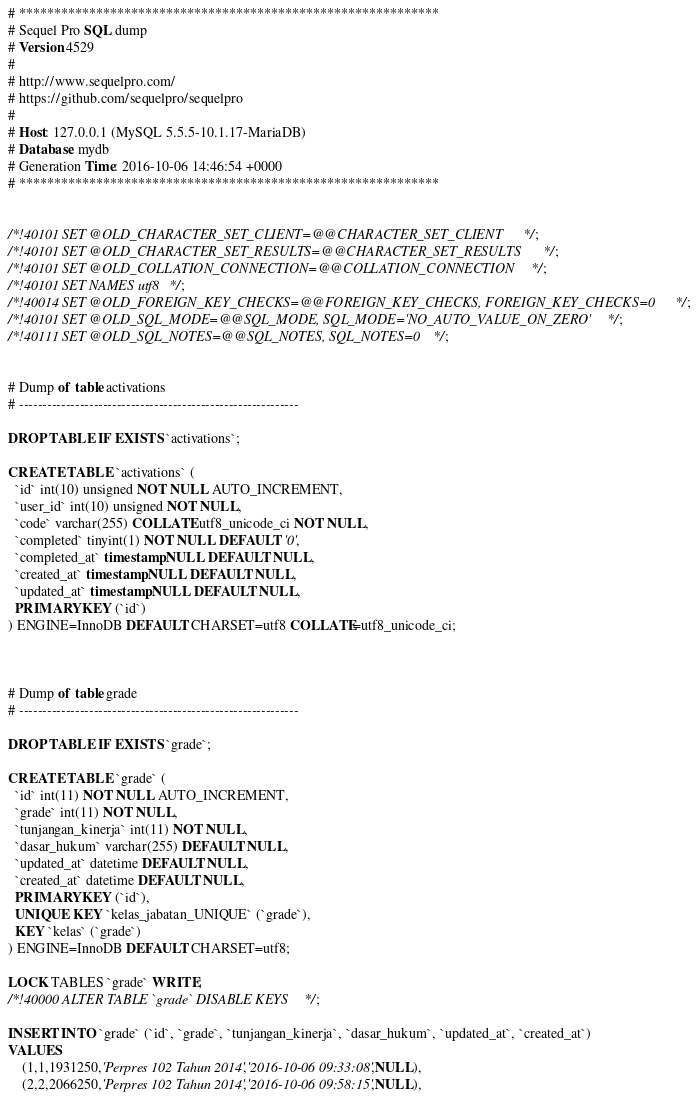<code> <loc_0><loc_0><loc_500><loc_500><_SQL_># ************************************************************
# Sequel Pro SQL dump
# Version 4529
#
# http://www.sequelpro.com/
# https://github.com/sequelpro/sequelpro
#
# Host: 127.0.0.1 (MySQL 5.5.5-10.1.17-MariaDB)
# Database: mydb
# Generation Time: 2016-10-06 14:46:54 +0000
# ************************************************************


/*!40101 SET @OLD_CHARACTER_SET_CLIENT=@@CHARACTER_SET_CLIENT */;
/*!40101 SET @OLD_CHARACTER_SET_RESULTS=@@CHARACTER_SET_RESULTS */;
/*!40101 SET @OLD_COLLATION_CONNECTION=@@COLLATION_CONNECTION */;
/*!40101 SET NAMES utf8 */;
/*!40014 SET @OLD_FOREIGN_KEY_CHECKS=@@FOREIGN_KEY_CHECKS, FOREIGN_KEY_CHECKS=0 */;
/*!40101 SET @OLD_SQL_MODE=@@SQL_MODE, SQL_MODE='NO_AUTO_VALUE_ON_ZERO' */;
/*!40111 SET @OLD_SQL_NOTES=@@SQL_NOTES, SQL_NOTES=0 */;


# Dump of table activations
# ------------------------------------------------------------

DROP TABLE IF EXISTS `activations`;

CREATE TABLE `activations` (
  `id` int(10) unsigned NOT NULL AUTO_INCREMENT,
  `user_id` int(10) unsigned NOT NULL,
  `code` varchar(255) COLLATE utf8_unicode_ci NOT NULL,
  `completed` tinyint(1) NOT NULL DEFAULT '0',
  `completed_at` timestamp NULL DEFAULT NULL,
  `created_at` timestamp NULL DEFAULT NULL,
  `updated_at` timestamp NULL DEFAULT NULL,
  PRIMARY KEY (`id`)
) ENGINE=InnoDB DEFAULT CHARSET=utf8 COLLATE=utf8_unicode_ci;



# Dump of table grade
# ------------------------------------------------------------

DROP TABLE IF EXISTS `grade`;

CREATE TABLE `grade` (
  `id` int(11) NOT NULL AUTO_INCREMENT,
  `grade` int(11) NOT NULL,
  `tunjangan_kinerja` int(11) NOT NULL,
  `dasar_hukum` varchar(255) DEFAULT NULL,
  `updated_at` datetime DEFAULT NULL,
  `created_at` datetime DEFAULT NULL,
  PRIMARY KEY (`id`),
  UNIQUE KEY `kelas_jabatan_UNIQUE` (`grade`),
  KEY `kelas` (`grade`)
) ENGINE=InnoDB DEFAULT CHARSET=utf8;

LOCK TABLES `grade` WRITE;
/*!40000 ALTER TABLE `grade` DISABLE KEYS */;

INSERT INTO `grade` (`id`, `grade`, `tunjangan_kinerja`, `dasar_hukum`, `updated_at`, `created_at`)
VALUES
	(1,1,1931250,'Perpres 102 Tahun 2014','2016-10-06 09:33:08',NULL),
	(2,2,2066250,'Perpres 102 Tahun 2014','2016-10-06 09:58:15',NULL),</code> 